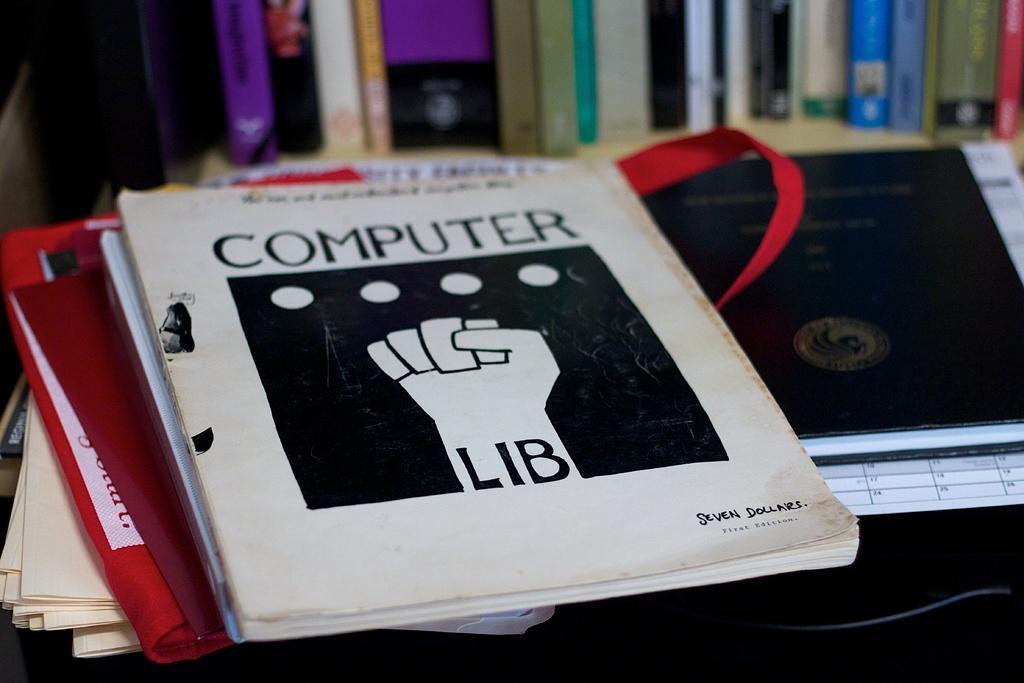Could you give a brief overview of what you see in this image? In this picture I can see there are few books placed on the table and in the backdrop I can see there is book shelf and there are books arranged in the shelf. 